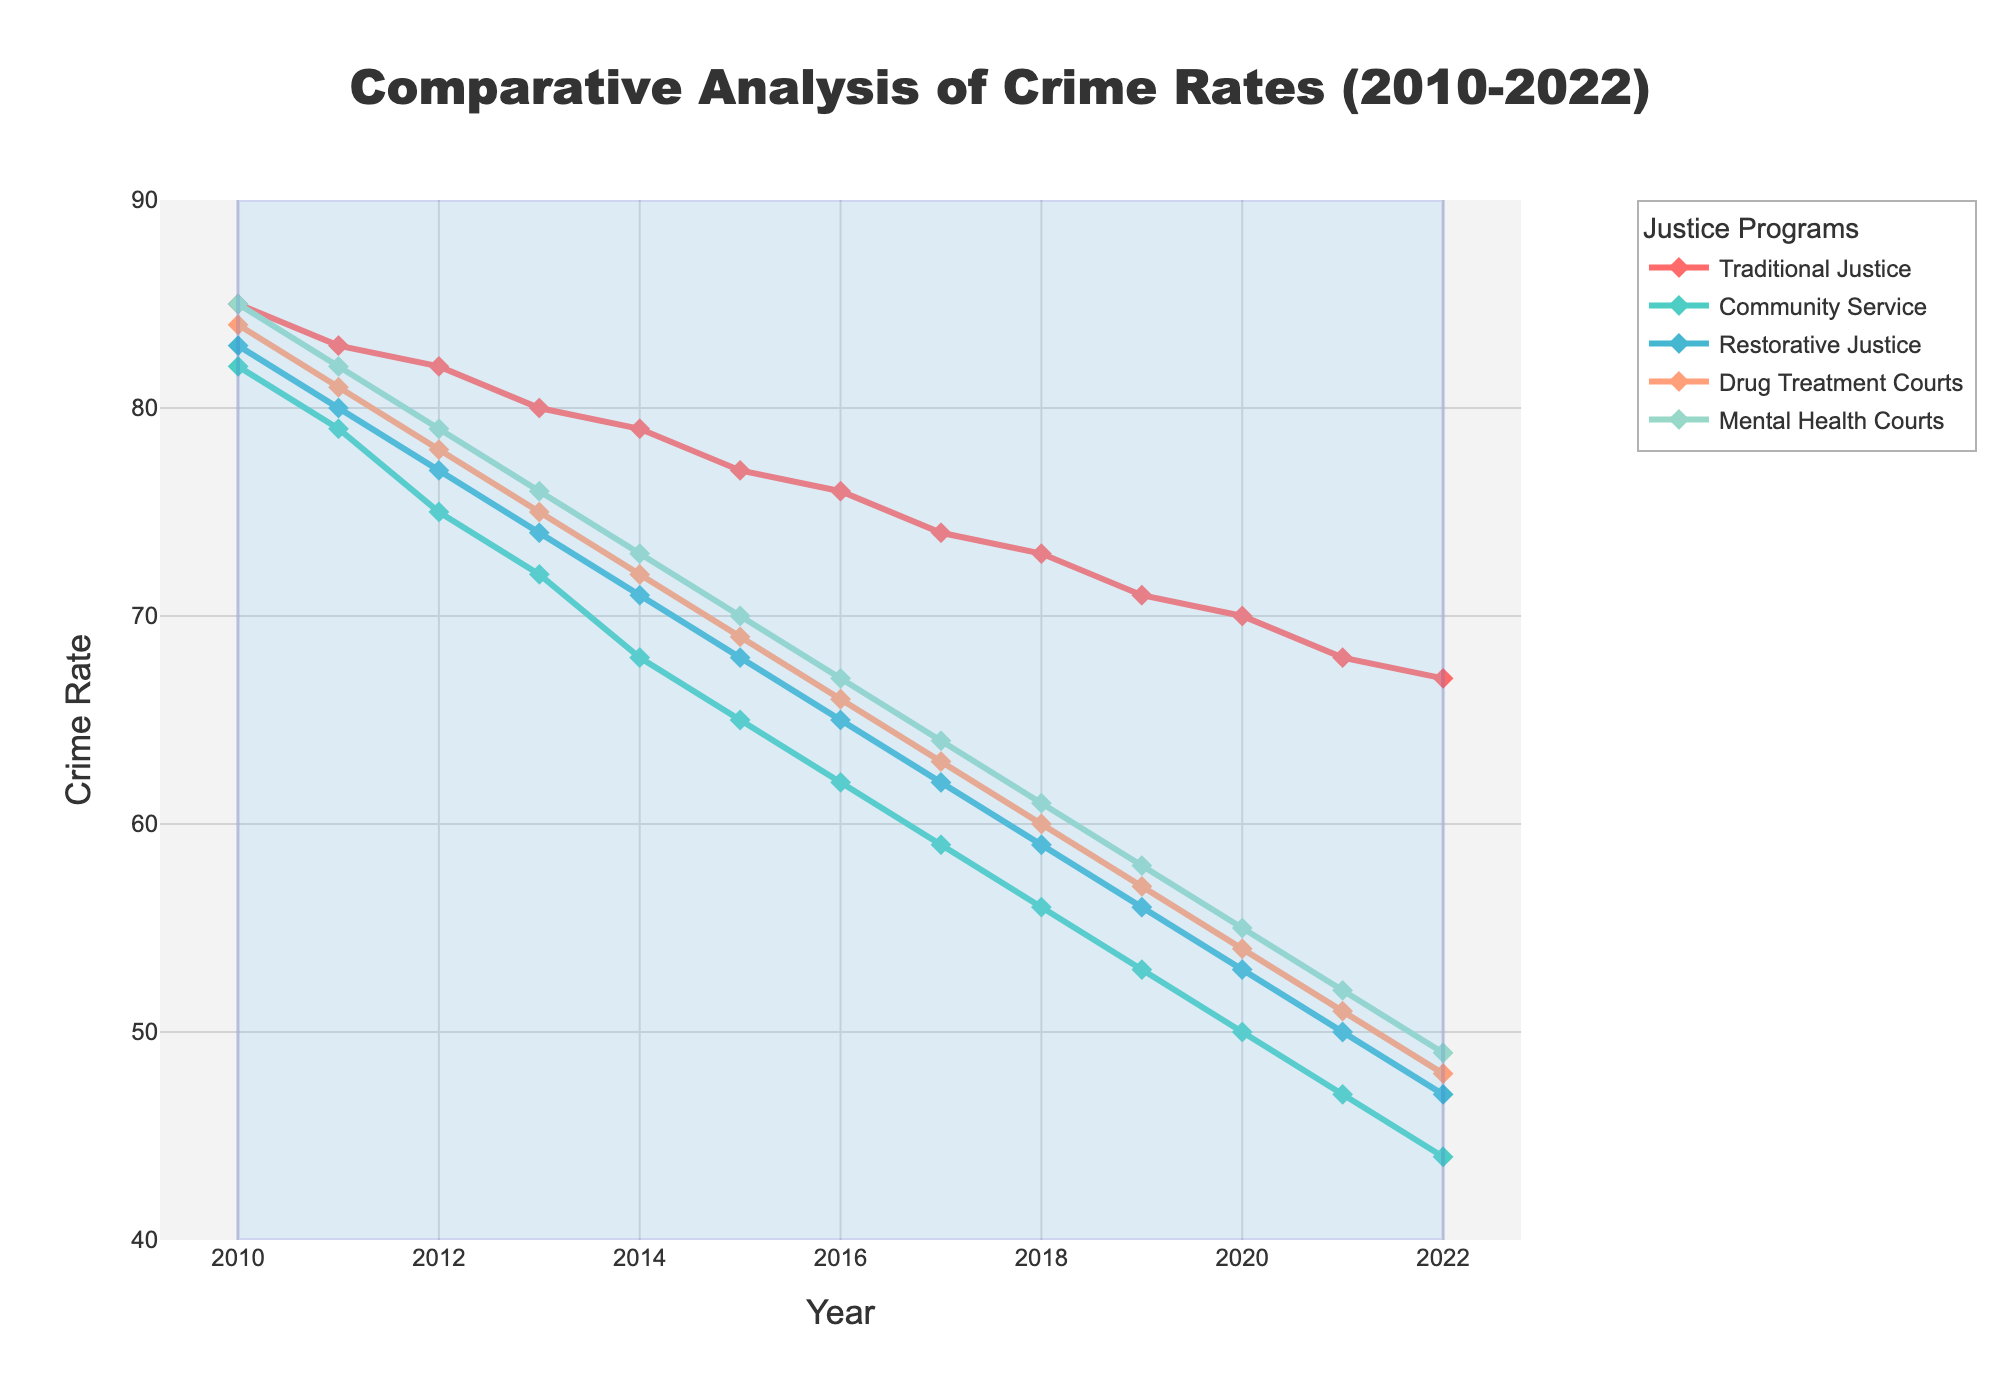what general trend can you observe in crime rates under all justice programs over the years? The overall trend seen in the figure is a decrease in crime rates across all justice programs from 2010 to 2022, indicating a possible positive effect of these programs over time.
Answer: Decreasing trend Which justice program shows the steepest decline in crime rates from 2010 to 2022? By comparing the slopes of the lines, the Community Service program shows the steepest decline in crime rates, dropping from 82 in 2010 to 44 in 2022.
Answer: Community Service By how much did the crime rate decrease for Drug Treatment Courts between 2010 and 2022? The crime rate for Drug Treatment Courts decreased from 84 in 2010 to 48 in 2022. The decrease is calculated by subtracting 48 from 84. (84 - 48 = 36)
Answer: 36 Which year shows the smallest difference in crime rates between the Traditional Justice and Community Service programs? By checking the visual distance between the curves representing Traditional Justice and Community Service, the smallest difference is observed in the year 2010 where Traditional Justice is at 85 and Community Service is 82, making the difference (85 - 82 = 3).
Answer: 2010 What was the crime rate for Mental Health Courts in 2016? The line representing Mental Health Courts in 2016 shows a value of 67.
Answer: 67 Which justice program had the highest crime rate in 2015, and what was the value? In 2015, the Traditional Justice program had the highest crime rate, reflected by the highest position on the plot, with a crime rate of 77.
Answer: Traditional Justice, 77 Did the crime rate for Restorative Justice in 2014 exceed that of Drug Treatment Courts in 2013? Restorative Justice in 2014 had a crime rate of 71, while Drug Treatment Courts in 2013 had a crime rate of 75. Since 71 < 75, the crime rate for Restorative Justice in 2014 did not exceed that of Drug Treatment Courts in 2013.
Answer: No Which justice program consistently had a lower crime rate than Traditional Justice from 2010 to 2022? By analyzing the positions of the lines relative to Traditional Justice, all four justice programs (Community Service, Restorative Justice, Drug Treatment Courts, and Mental Health Courts) had consistently lower crime rates than Traditional Justice throughout the years 2010 to 2022.
Answer: All programs What is the average crime rate for the Restorative Justice program over the years 2010 to 2022? The sum of the crime rates for Restorative Justice from 2010 to 2022 is (83 + 80 + 77 + 74 + 71 + 68 + 65 + 62 + 59 + 56 + 53 + 50 + 47) = 845. The number of years is 13. So the average crime rate is 845 / 13 ≈ 65.
Answer: 65 How does the 2022 crime rate for Mental Health Courts compare to that for Community Service in the same year? In 2022, Mental Health Courts had a crime rate of 49, while Community Service had a crime rate of 44. Therefore, the crime rate for Mental Health Courts was higher than that for Community Service by (49 - 44 = 5).
Answer: Higher by 5 